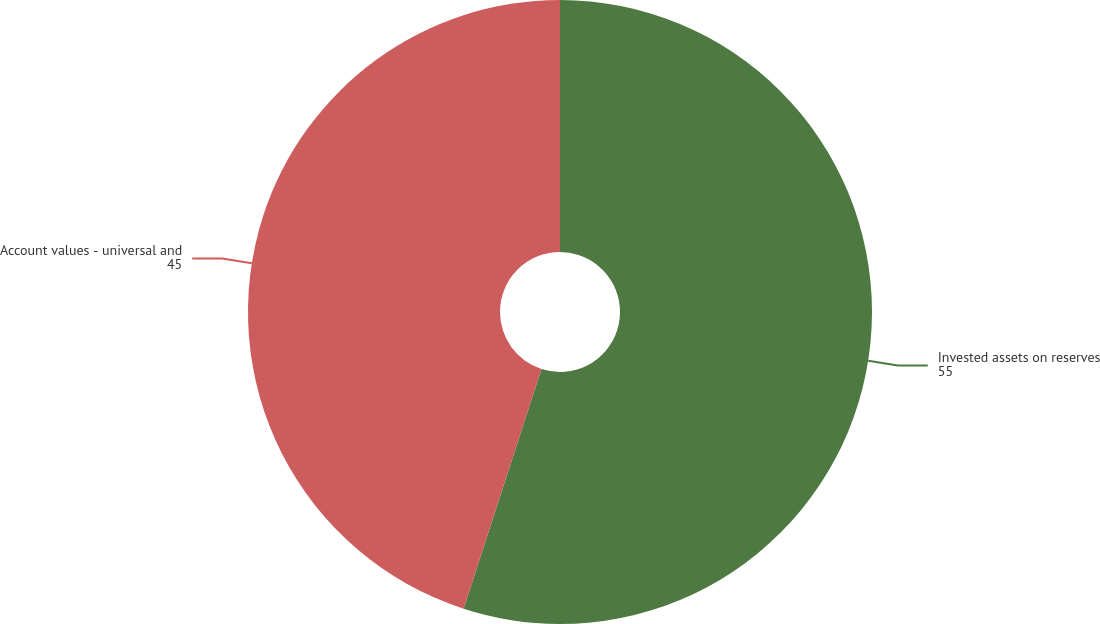Convert chart. <chart><loc_0><loc_0><loc_500><loc_500><pie_chart><fcel>Invested assets on reserves<fcel>Account values - universal and<nl><fcel>55.0%<fcel>45.0%<nl></chart> 